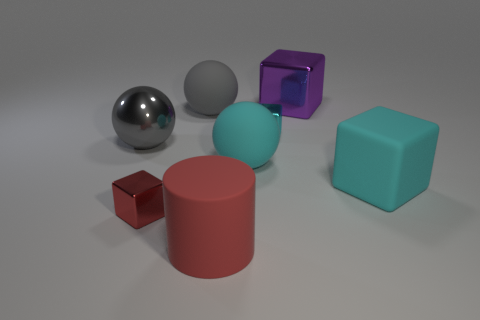What number of objects are tiny metal blocks that are on the right side of the large gray matte object or cyan metal blocks to the right of the tiny red metallic block?
Make the answer very short. 1. There is a sphere that is behind the gray metallic sphere; does it have the same color as the big matte cylinder?
Provide a succinct answer. No. How many matte things are either tiny blue cubes or large blocks?
Make the answer very short. 1. What is the shape of the purple metal object?
Ensure brevity in your answer.  Cube. Are there any other things that are made of the same material as the purple cube?
Offer a terse response. Yes. Is the tiny red thing made of the same material as the purple object?
Your answer should be compact. Yes. There is a large cyan ball in front of the tiny cube behind the cyan rubber cube; is there a big object to the left of it?
Provide a short and direct response. Yes. How many other objects are the same shape as the big gray matte thing?
Make the answer very short. 2. There is a shiny thing that is both on the left side of the red cylinder and behind the red shiny thing; what is its shape?
Your response must be concise. Sphere. There is a metallic thing that is behind the cyan thing behind the rubber sphere to the right of the large matte cylinder; what color is it?
Your answer should be very brief. Purple. 